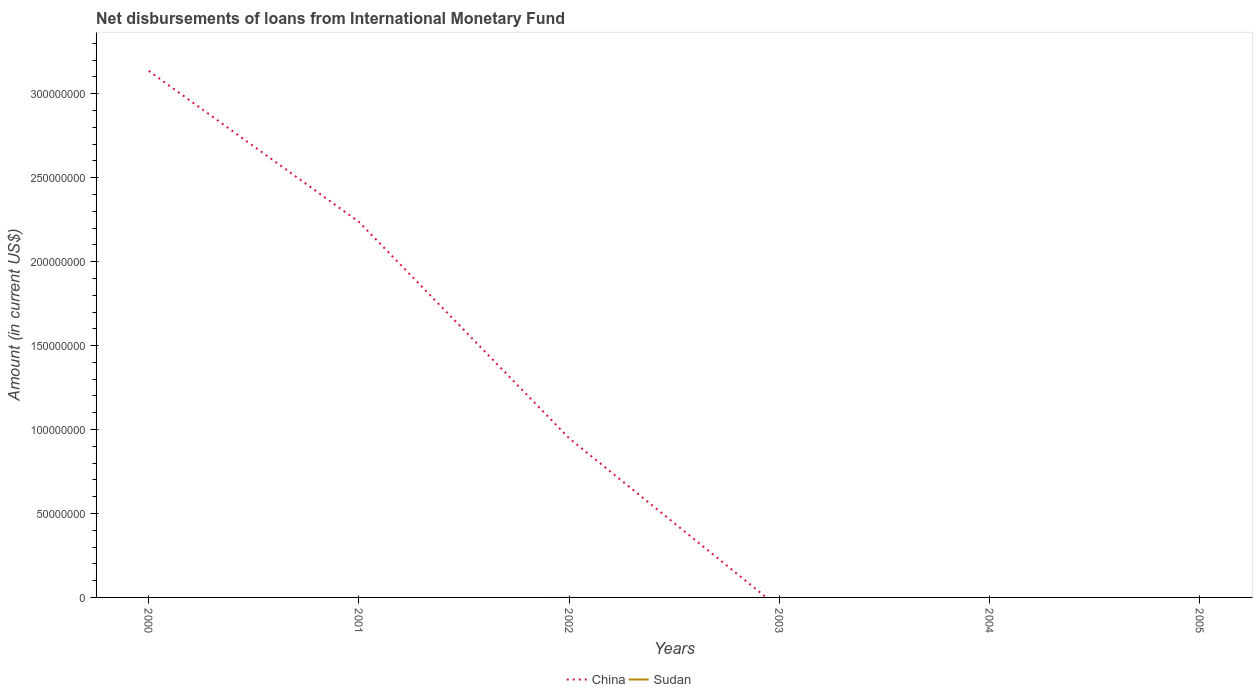How many different coloured lines are there?
Your answer should be very brief. 1. Is the number of lines equal to the number of legend labels?
Your response must be concise. No. What is the total amount of loans disbursed in China in the graph?
Provide a short and direct response. 1.29e+08. What is the difference between the highest and the lowest amount of loans disbursed in China?
Your response must be concise. 2. Is the amount of loans disbursed in Sudan strictly greater than the amount of loans disbursed in China over the years?
Your answer should be very brief. No. How many lines are there?
Your answer should be very brief. 1. What is the difference between two consecutive major ticks on the Y-axis?
Make the answer very short. 5.00e+07. Are the values on the major ticks of Y-axis written in scientific E-notation?
Provide a short and direct response. No. Does the graph contain any zero values?
Offer a terse response. Yes. How many legend labels are there?
Provide a short and direct response. 2. How are the legend labels stacked?
Your answer should be very brief. Horizontal. What is the title of the graph?
Give a very brief answer. Net disbursements of loans from International Monetary Fund. Does "Ghana" appear as one of the legend labels in the graph?
Your answer should be very brief. No. What is the label or title of the Y-axis?
Offer a very short reply. Amount (in current US$). What is the Amount (in current US$) of China in 2000?
Give a very brief answer. 3.14e+08. What is the Amount (in current US$) in China in 2001?
Offer a very short reply. 2.24e+08. What is the Amount (in current US$) of China in 2002?
Ensure brevity in your answer.  9.47e+07. What is the Amount (in current US$) in Sudan in 2003?
Your answer should be very brief. 0. What is the Amount (in current US$) in China in 2004?
Provide a succinct answer. 0. What is the Amount (in current US$) of China in 2005?
Make the answer very short. 0. Across all years, what is the maximum Amount (in current US$) in China?
Make the answer very short. 3.14e+08. What is the total Amount (in current US$) of China in the graph?
Provide a succinct answer. 6.32e+08. What is the total Amount (in current US$) of Sudan in the graph?
Make the answer very short. 0. What is the difference between the Amount (in current US$) in China in 2000 and that in 2001?
Provide a succinct answer. 9.00e+07. What is the difference between the Amount (in current US$) of China in 2000 and that in 2002?
Keep it short and to the point. 2.19e+08. What is the difference between the Amount (in current US$) in China in 2001 and that in 2002?
Your answer should be compact. 1.29e+08. What is the average Amount (in current US$) in China per year?
Keep it short and to the point. 1.05e+08. What is the ratio of the Amount (in current US$) in China in 2000 to that in 2001?
Your answer should be compact. 1.4. What is the ratio of the Amount (in current US$) in China in 2000 to that in 2002?
Your response must be concise. 3.31. What is the ratio of the Amount (in current US$) in China in 2001 to that in 2002?
Provide a succinct answer. 2.36. What is the difference between the highest and the second highest Amount (in current US$) of China?
Make the answer very short. 9.00e+07. What is the difference between the highest and the lowest Amount (in current US$) of China?
Give a very brief answer. 3.14e+08. 